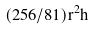<formula> <loc_0><loc_0><loc_500><loc_500>( 2 5 6 / 8 1 ) r ^ { 2 } h</formula> 